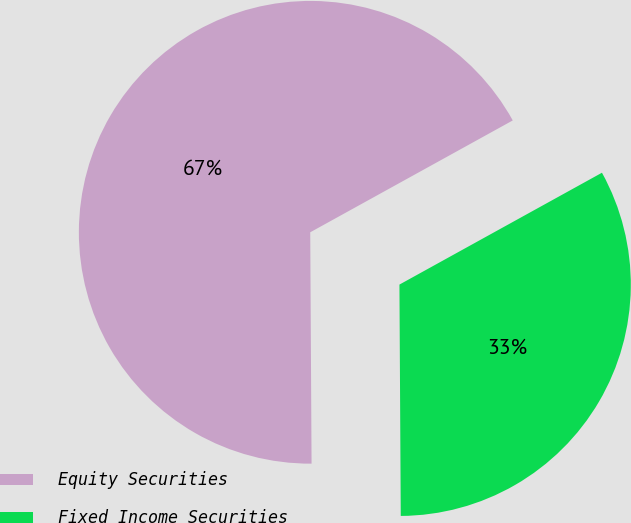<chart> <loc_0><loc_0><loc_500><loc_500><pie_chart><fcel>Equity Securities<fcel>Fixed Income Securities<nl><fcel>67.06%<fcel>32.94%<nl></chart> 